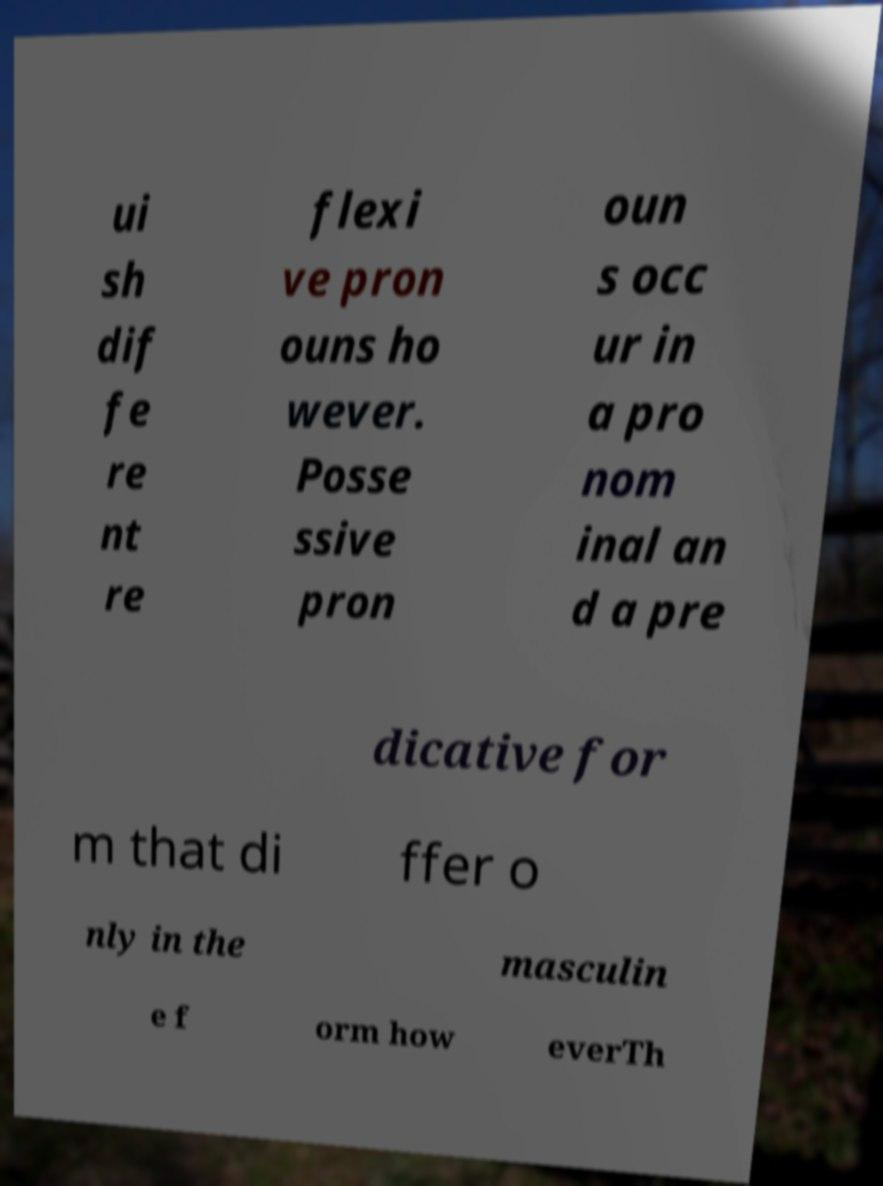Please read and relay the text visible in this image. What does it say? ui sh dif fe re nt re flexi ve pron ouns ho wever. Posse ssive pron oun s occ ur in a pro nom inal an d a pre dicative for m that di ffer o nly in the masculin e f orm how everTh 